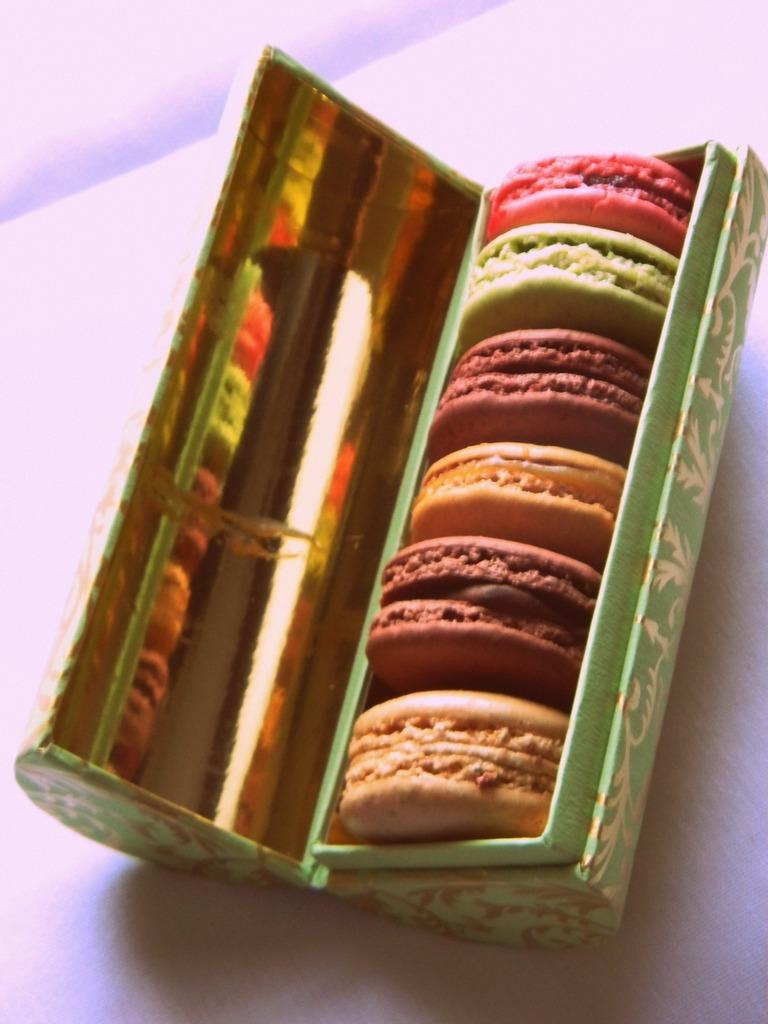What type of food can be seen in the image? There are cookies in the image. How are the cookies stored or contained? The cookies are in a box. On what surface is the box of cookies placed? The box is on a white surface. What time of day is depicted in the image? The image does not depict a specific time of day, as it only shows cookies in a box on a white surface. 